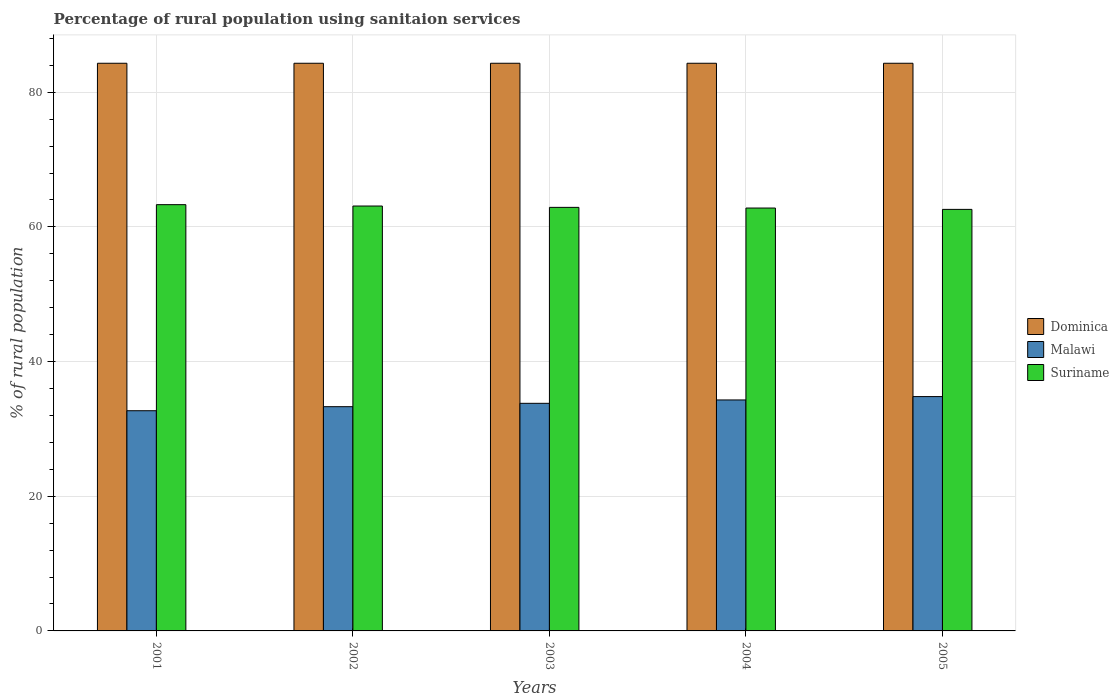How many different coloured bars are there?
Keep it short and to the point. 3. Are the number of bars per tick equal to the number of legend labels?
Make the answer very short. Yes. How many bars are there on the 4th tick from the right?
Give a very brief answer. 3. What is the percentage of rural population using sanitaion services in Suriname in 2004?
Your answer should be very brief. 62.8. Across all years, what is the maximum percentage of rural population using sanitaion services in Malawi?
Offer a terse response. 34.8. Across all years, what is the minimum percentage of rural population using sanitaion services in Malawi?
Make the answer very short. 32.7. In which year was the percentage of rural population using sanitaion services in Dominica maximum?
Provide a short and direct response. 2001. What is the total percentage of rural population using sanitaion services in Malawi in the graph?
Provide a succinct answer. 168.9. What is the difference between the percentage of rural population using sanitaion services in Malawi in 2005 and the percentage of rural population using sanitaion services in Suriname in 2004?
Your response must be concise. -28. What is the average percentage of rural population using sanitaion services in Dominica per year?
Offer a terse response. 84.3. In the year 2001, what is the difference between the percentage of rural population using sanitaion services in Malawi and percentage of rural population using sanitaion services in Dominica?
Your answer should be compact. -51.6. What is the ratio of the percentage of rural population using sanitaion services in Dominica in 2004 to that in 2005?
Offer a terse response. 1. Is the difference between the percentage of rural population using sanitaion services in Malawi in 2001 and 2005 greater than the difference between the percentage of rural population using sanitaion services in Dominica in 2001 and 2005?
Your answer should be very brief. No. What is the difference between the highest and the second highest percentage of rural population using sanitaion services in Malawi?
Provide a succinct answer. 0.5. What does the 1st bar from the left in 2004 represents?
Provide a short and direct response. Dominica. What does the 2nd bar from the right in 2005 represents?
Provide a short and direct response. Malawi. Is it the case that in every year, the sum of the percentage of rural population using sanitaion services in Malawi and percentage of rural population using sanitaion services in Suriname is greater than the percentage of rural population using sanitaion services in Dominica?
Keep it short and to the point. Yes. How many years are there in the graph?
Ensure brevity in your answer.  5. What is the difference between two consecutive major ticks on the Y-axis?
Provide a succinct answer. 20. Does the graph contain any zero values?
Give a very brief answer. No. Where does the legend appear in the graph?
Provide a succinct answer. Center right. How are the legend labels stacked?
Keep it short and to the point. Vertical. What is the title of the graph?
Give a very brief answer. Percentage of rural population using sanitaion services. What is the label or title of the Y-axis?
Make the answer very short. % of rural population. What is the % of rural population in Dominica in 2001?
Your answer should be very brief. 84.3. What is the % of rural population of Malawi in 2001?
Offer a very short reply. 32.7. What is the % of rural population of Suriname in 2001?
Make the answer very short. 63.3. What is the % of rural population of Dominica in 2002?
Provide a succinct answer. 84.3. What is the % of rural population in Malawi in 2002?
Offer a very short reply. 33.3. What is the % of rural population of Suriname in 2002?
Your answer should be compact. 63.1. What is the % of rural population of Dominica in 2003?
Your answer should be very brief. 84.3. What is the % of rural population in Malawi in 2003?
Your response must be concise. 33.8. What is the % of rural population of Suriname in 2003?
Your answer should be compact. 62.9. What is the % of rural population in Dominica in 2004?
Give a very brief answer. 84.3. What is the % of rural population of Malawi in 2004?
Your response must be concise. 34.3. What is the % of rural population of Suriname in 2004?
Ensure brevity in your answer.  62.8. What is the % of rural population of Dominica in 2005?
Offer a very short reply. 84.3. What is the % of rural population in Malawi in 2005?
Your response must be concise. 34.8. What is the % of rural population of Suriname in 2005?
Give a very brief answer. 62.6. Across all years, what is the maximum % of rural population in Dominica?
Make the answer very short. 84.3. Across all years, what is the maximum % of rural population in Malawi?
Offer a terse response. 34.8. Across all years, what is the maximum % of rural population of Suriname?
Your answer should be very brief. 63.3. Across all years, what is the minimum % of rural population of Dominica?
Ensure brevity in your answer.  84.3. Across all years, what is the minimum % of rural population in Malawi?
Your answer should be compact. 32.7. Across all years, what is the minimum % of rural population of Suriname?
Offer a terse response. 62.6. What is the total % of rural population of Dominica in the graph?
Give a very brief answer. 421.5. What is the total % of rural population of Malawi in the graph?
Offer a terse response. 168.9. What is the total % of rural population of Suriname in the graph?
Make the answer very short. 314.7. What is the difference between the % of rural population in Malawi in 2001 and that in 2004?
Your response must be concise. -1.6. What is the difference between the % of rural population of Suriname in 2002 and that in 2003?
Make the answer very short. 0.2. What is the difference between the % of rural population in Malawi in 2002 and that in 2004?
Your answer should be compact. -1. What is the difference between the % of rural population of Dominica in 2002 and that in 2005?
Give a very brief answer. 0. What is the difference between the % of rural population of Malawi in 2002 and that in 2005?
Offer a very short reply. -1.5. What is the difference between the % of rural population in Suriname in 2002 and that in 2005?
Provide a succinct answer. 0.5. What is the difference between the % of rural population of Malawi in 2003 and that in 2004?
Provide a short and direct response. -0.5. What is the difference between the % of rural population of Suriname in 2003 and that in 2005?
Offer a terse response. 0.3. What is the difference between the % of rural population in Dominica in 2004 and that in 2005?
Ensure brevity in your answer.  0. What is the difference between the % of rural population of Malawi in 2004 and that in 2005?
Make the answer very short. -0.5. What is the difference between the % of rural population of Dominica in 2001 and the % of rural population of Suriname in 2002?
Offer a very short reply. 21.2. What is the difference between the % of rural population of Malawi in 2001 and the % of rural population of Suriname in 2002?
Keep it short and to the point. -30.4. What is the difference between the % of rural population of Dominica in 2001 and the % of rural population of Malawi in 2003?
Your answer should be very brief. 50.5. What is the difference between the % of rural population of Dominica in 2001 and the % of rural population of Suriname in 2003?
Provide a short and direct response. 21.4. What is the difference between the % of rural population of Malawi in 2001 and the % of rural population of Suriname in 2003?
Make the answer very short. -30.2. What is the difference between the % of rural population in Malawi in 2001 and the % of rural population in Suriname in 2004?
Your answer should be very brief. -30.1. What is the difference between the % of rural population of Dominica in 2001 and the % of rural population of Malawi in 2005?
Provide a short and direct response. 49.5. What is the difference between the % of rural population in Dominica in 2001 and the % of rural population in Suriname in 2005?
Give a very brief answer. 21.7. What is the difference between the % of rural population of Malawi in 2001 and the % of rural population of Suriname in 2005?
Offer a terse response. -29.9. What is the difference between the % of rural population of Dominica in 2002 and the % of rural population of Malawi in 2003?
Offer a very short reply. 50.5. What is the difference between the % of rural population in Dominica in 2002 and the % of rural population in Suriname in 2003?
Ensure brevity in your answer.  21.4. What is the difference between the % of rural population in Malawi in 2002 and the % of rural population in Suriname in 2003?
Offer a terse response. -29.6. What is the difference between the % of rural population of Dominica in 2002 and the % of rural population of Suriname in 2004?
Your answer should be compact. 21.5. What is the difference between the % of rural population in Malawi in 2002 and the % of rural population in Suriname in 2004?
Offer a terse response. -29.5. What is the difference between the % of rural population of Dominica in 2002 and the % of rural population of Malawi in 2005?
Offer a very short reply. 49.5. What is the difference between the % of rural population in Dominica in 2002 and the % of rural population in Suriname in 2005?
Offer a very short reply. 21.7. What is the difference between the % of rural population in Malawi in 2002 and the % of rural population in Suriname in 2005?
Provide a short and direct response. -29.3. What is the difference between the % of rural population in Dominica in 2003 and the % of rural population in Suriname in 2004?
Keep it short and to the point. 21.5. What is the difference between the % of rural population of Malawi in 2003 and the % of rural population of Suriname in 2004?
Your response must be concise. -29. What is the difference between the % of rural population in Dominica in 2003 and the % of rural population in Malawi in 2005?
Provide a short and direct response. 49.5. What is the difference between the % of rural population of Dominica in 2003 and the % of rural population of Suriname in 2005?
Offer a very short reply. 21.7. What is the difference between the % of rural population in Malawi in 2003 and the % of rural population in Suriname in 2005?
Your answer should be very brief. -28.8. What is the difference between the % of rural population of Dominica in 2004 and the % of rural population of Malawi in 2005?
Give a very brief answer. 49.5. What is the difference between the % of rural population of Dominica in 2004 and the % of rural population of Suriname in 2005?
Give a very brief answer. 21.7. What is the difference between the % of rural population of Malawi in 2004 and the % of rural population of Suriname in 2005?
Make the answer very short. -28.3. What is the average % of rural population of Dominica per year?
Keep it short and to the point. 84.3. What is the average % of rural population in Malawi per year?
Provide a short and direct response. 33.78. What is the average % of rural population of Suriname per year?
Offer a very short reply. 62.94. In the year 2001, what is the difference between the % of rural population in Dominica and % of rural population in Malawi?
Offer a terse response. 51.6. In the year 2001, what is the difference between the % of rural population of Malawi and % of rural population of Suriname?
Your answer should be very brief. -30.6. In the year 2002, what is the difference between the % of rural population of Dominica and % of rural population of Suriname?
Offer a terse response. 21.2. In the year 2002, what is the difference between the % of rural population of Malawi and % of rural population of Suriname?
Your answer should be compact. -29.8. In the year 2003, what is the difference between the % of rural population in Dominica and % of rural population in Malawi?
Provide a succinct answer. 50.5. In the year 2003, what is the difference between the % of rural population of Dominica and % of rural population of Suriname?
Your answer should be compact. 21.4. In the year 2003, what is the difference between the % of rural population of Malawi and % of rural population of Suriname?
Make the answer very short. -29.1. In the year 2004, what is the difference between the % of rural population in Dominica and % of rural population in Malawi?
Your answer should be very brief. 50. In the year 2004, what is the difference between the % of rural population of Dominica and % of rural population of Suriname?
Offer a very short reply. 21.5. In the year 2004, what is the difference between the % of rural population of Malawi and % of rural population of Suriname?
Offer a very short reply. -28.5. In the year 2005, what is the difference between the % of rural population of Dominica and % of rural population of Malawi?
Your answer should be compact. 49.5. In the year 2005, what is the difference between the % of rural population in Dominica and % of rural population in Suriname?
Provide a short and direct response. 21.7. In the year 2005, what is the difference between the % of rural population in Malawi and % of rural population in Suriname?
Make the answer very short. -27.8. What is the ratio of the % of rural population of Dominica in 2001 to that in 2003?
Give a very brief answer. 1. What is the ratio of the % of rural population of Malawi in 2001 to that in 2003?
Provide a short and direct response. 0.97. What is the ratio of the % of rural population of Suriname in 2001 to that in 2003?
Provide a short and direct response. 1.01. What is the ratio of the % of rural population of Malawi in 2001 to that in 2004?
Your answer should be compact. 0.95. What is the ratio of the % of rural population of Malawi in 2001 to that in 2005?
Make the answer very short. 0.94. What is the ratio of the % of rural population in Suriname in 2001 to that in 2005?
Ensure brevity in your answer.  1.01. What is the ratio of the % of rural population of Malawi in 2002 to that in 2003?
Your answer should be very brief. 0.99. What is the ratio of the % of rural population in Suriname in 2002 to that in 2003?
Make the answer very short. 1. What is the ratio of the % of rural population in Dominica in 2002 to that in 2004?
Your response must be concise. 1. What is the ratio of the % of rural population in Malawi in 2002 to that in 2004?
Your answer should be compact. 0.97. What is the ratio of the % of rural population in Malawi in 2002 to that in 2005?
Your response must be concise. 0.96. What is the ratio of the % of rural population in Malawi in 2003 to that in 2004?
Provide a short and direct response. 0.99. What is the ratio of the % of rural population of Malawi in 2003 to that in 2005?
Offer a very short reply. 0.97. What is the ratio of the % of rural population in Suriname in 2003 to that in 2005?
Make the answer very short. 1. What is the ratio of the % of rural population in Malawi in 2004 to that in 2005?
Ensure brevity in your answer.  0.99. What is the difference between the highest and the second highest % of rural population in Malawi?
Offer a terse response. 0.5. What is the difference between the highest and the second highest % of rural population of Suriname?
Provide a succinct answer. 0.2. What is the difference between the highest and the lowest % of rural population in Suriname?
Your response must be concise. 0.7. 